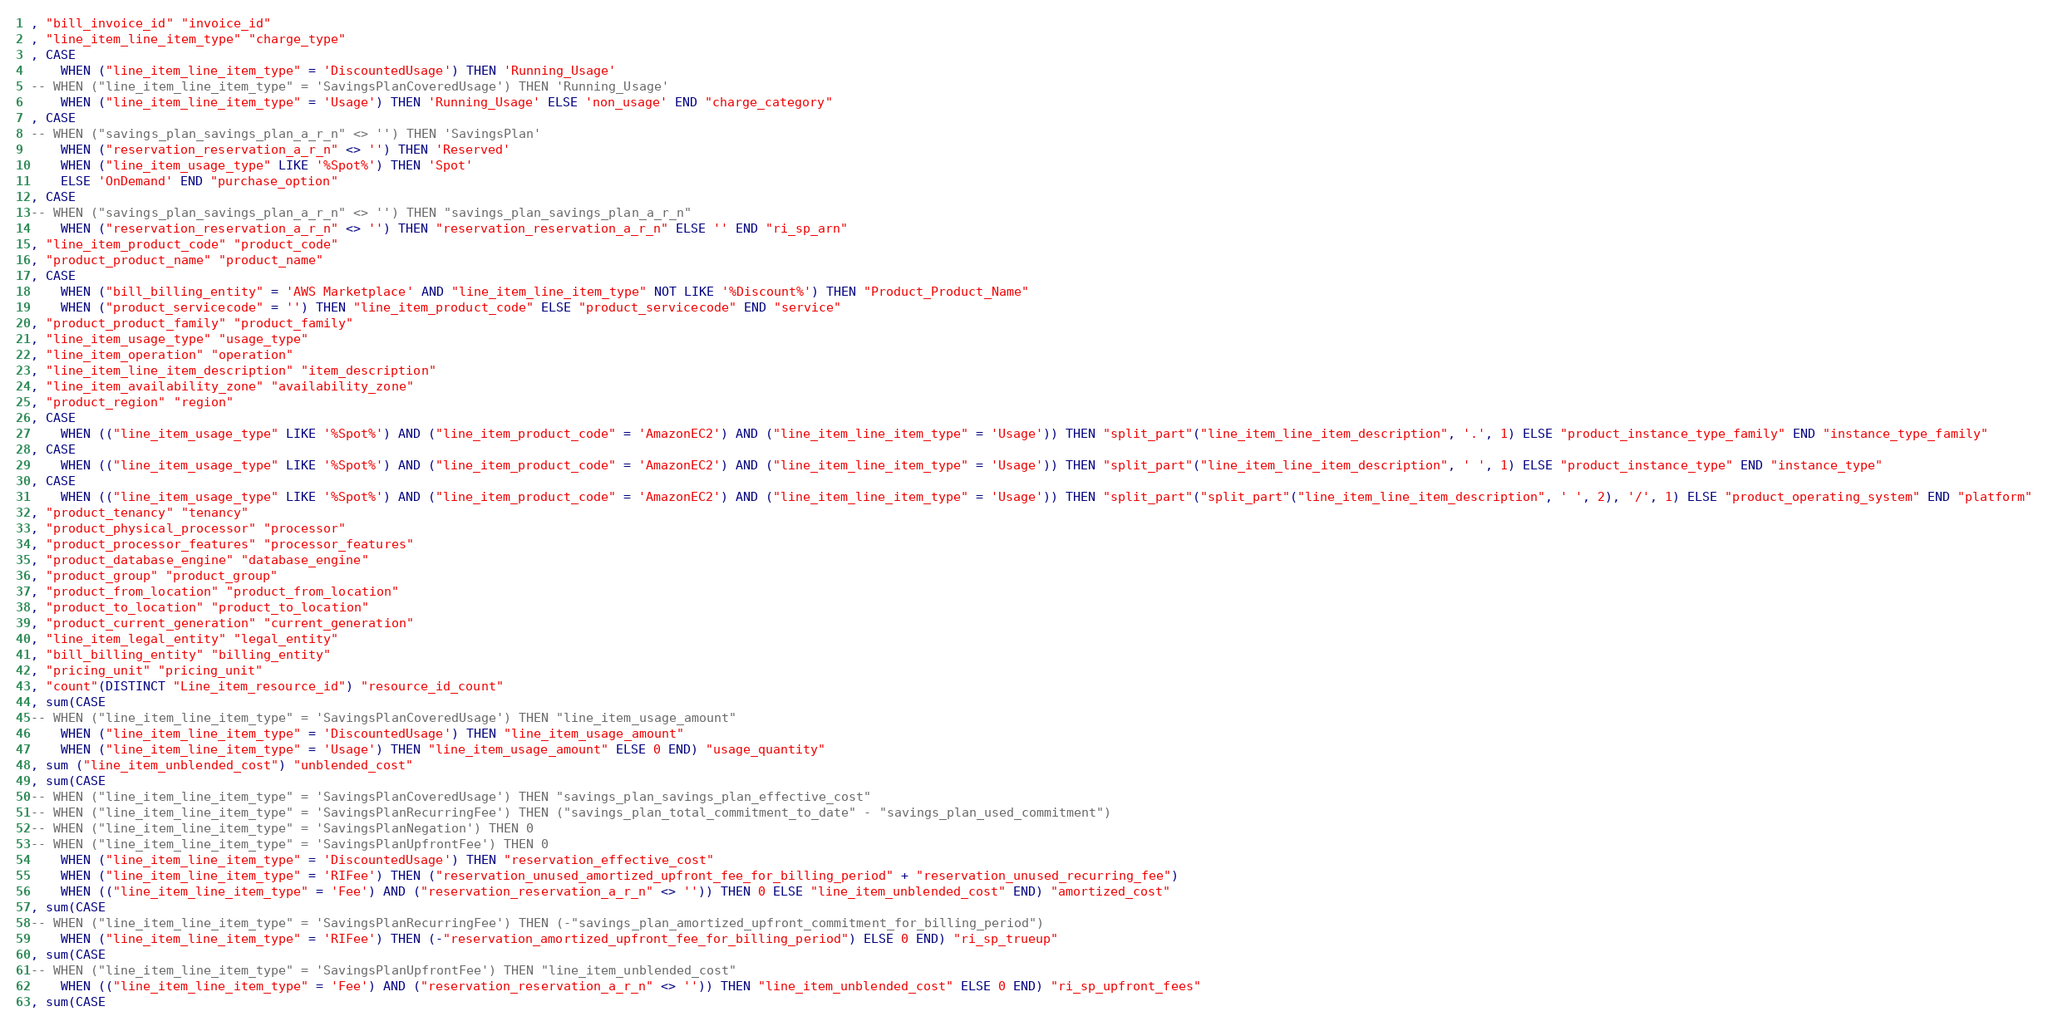Convert code to text. <code><loc_0><loc_0><loc_500><loc_500><_SQL_> , "bill_invoice_id" "invoice_id"
 , "line_item_line_item_type" "charge_type"
 , CASE
     WHEN ("line_item_line_item_type" = 'DiscountedUsage') THEN 'Running_Usage'
 -- WHEN ("line_item_line_item_type" = 'SavingsPlanCoveredUsage') THEN 'Running_Usage'
     WHEN ("line_item_line_item_type" = 'Usage') THEN 'Running_Usage' ELSE 'non_usage' END "charge_category"
 , CASE
 -- WHEN ("savings_plan_savings_plan_a_r_n" <> '') THEN 'SavingsPlan'
     WHEN ("reservation_reservation_a_r_n" <> '') THEN 'Reserved'
     WHEN ("line_item_usage_type" LIKE '%Spot%') THEN 'Spot'
     ELSE 'OnDemand' END "purchase_option"
 , CASE
 -- WHEN ("savings_plan_savings_plan_a_r_n" <> '') THEN "savings_plan_savings_plan_a_r_n"
     WHEN ("reservation_reservation_a_r_n" <> '') THEN "reservation_reservation_a_r_n" ELSE '' END "ri_sp_arn"
 , "line_item_product_code" "product_code"
 , "product_product_name" "product_name"
 , CASE
     WHEN ("bill_billing_entity" = 'AWS Marketplace' AND "line_item_line_item_type" NOT LIKE '%Discount%') THEN "Product_Product_Name"
     WHEN ("product_servicecode" = '') THEN "line_item_product_code" ELSE "product_servicecode" END "service"
 , "product_product_family" "product_family"
 , "line_item_usage_type" "usage_type"
 , "line_item_operation" "operation"
 , "line_item_line_item_description" "item_description"
 , "line_item_availability_zone" "availability_zone"
 , "product_region" "region"
 , CASE
     WHEN (("line_item_usage_type" LIKE '%Spot%') AND ("line_item_product_code" = 'AmazonEC2') AND ("line_item_line_item_type" = 'Usage')) THEN "split_part"("line_item_line_item_description", '.', 1) ELSE "product_instance_type_family" END "instance_type_family"
 , CASE
     WHEN (("line_item_usage_type" LIKE '%Spot%') AND ("line_item_product_code" = 'AmazonEC2') AND ("line_item_line_item_type" = 'Usage')) THEN "split_part"("line_item_line_item_description", ' ', 1) ELSE "product_instance_type" END "instance_type"
 , CASE
     WHEN (("line_item_usage_type" LIKE '%Spot%') AND ("line_item_product_code" = 'AmazonEC2') AND ("line_item_line_item_type" = 'Usage')) THEN "split_part"("split_part"("line_item_line_item_description", ' ', 2), '/', 1) ELSE "product_operating_system" END "platform"
 , "product_tenancy" "tenancy"
 , "product_physical_processor" "processor"
 , "product_processor_features" "processor_features"
 , "product_database_engine" "database_engine"
 , "product_group" "product_group"
 , "product_from_location" "product_from_location"
 , "product_to_location" "product_to_location"
 , "product_current_generation" "current_generation"
 , "line_item_legal_entity" "legal_entity"
 , "bill_billing_entity" "billing_entity"
 , "pricing_unit" "pricing_unit"
 , "count"(DISTINCT "Line_item_resource_id") "resource_id_count"
 , sum(CASE
 -- WHEN ("line_item_line_item_type" = 'SavingsPlanCoveredUsage') THEN "line_item_usage_amount"
     WHEN ("line_item_line_item_type" = 'DiscountedUsage') THEN "line_item_usage_amount"
     WHEN ("line_item_line_item_type" = 'Usage') THEN "line_item_usage_amount" ELSE 0 END) "usage_quantity"
 , sum ("line_item_unblended_cost") "unblended_cost"
 , sum(CASE
 -- WHEN ("line_item_line_item_type" = 'SavingsPlanCoveredUsage') THEN "savings_plan_savings_plan_effective_cost"
 -- WHEN ("line_item_line_item_type" = 'SavingsPlanRecurringFee') THEN ("savings_plan_total_commitment_to_date" - "savings_plan_used_commitment")
 -- WHEN ("line_item_line_item_type" = 'SavingsPlanNegation') THEN 0
 -- WHEN ("line_item_line_item_type" = 'SavingsPlanUpfrontFee') THEN 0
     WHEN ("line_item_line_item_type" = 'DiscountedUsage') THEN "reservation_effective_cost"
     WHEN ("line_item_line_item_type" = 'RIFee') THEN ("reservation_unused_amortized_upfront_fee_for_billing_period" + "reservation_unused_recurring_fee")
     WHEN (("line_item_line_item_type" = 'Fee') AND ("reservation_reservation_a_r_n" <> '')) THEN 0 ELSE "line_item_unblended_cost" END) "amortized_cost"
 , sum(CASE
 -- WHEN ("line_item_line_item_type" = 'SavingsPlanRecurringFee') THEN (-"savings_plan_amortized_upfront_commitment_for_billing_period")
     WHEN ("line_item_line_item_type" = 'RIFee') THEN (-"reservation_amortized_upfront_fee_for_billing_period") ELSE 0 END) "ri_sp_trueup"
 , sum(CASE
 -- WHEN ("line_item_line_item_type" = 'SavingsPlanUpfrontFee') THEN "line_item_unblended_cost"
     WHEN (("line_item_line_item_type" = 'Fee') AND ("reservation_reservation_a_r_n" <> '')) THEN "line_item_unblended_cost" ELSE 0 END) "ri_sp_upfront_fees"
 , sum(CASE</code> 